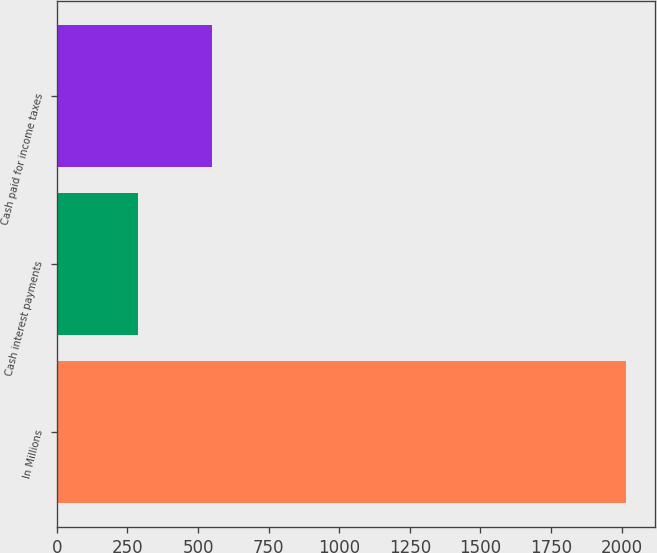<chart> <loc_0><loc_0><loc_500><loc_500><bar_chart><fcel>In Millions<fcel>Cash interest payments<fcel>Cash paid for income taxes<nl><fcel>2017<fcel>285.8<fcel>551.1<nl></chart> 